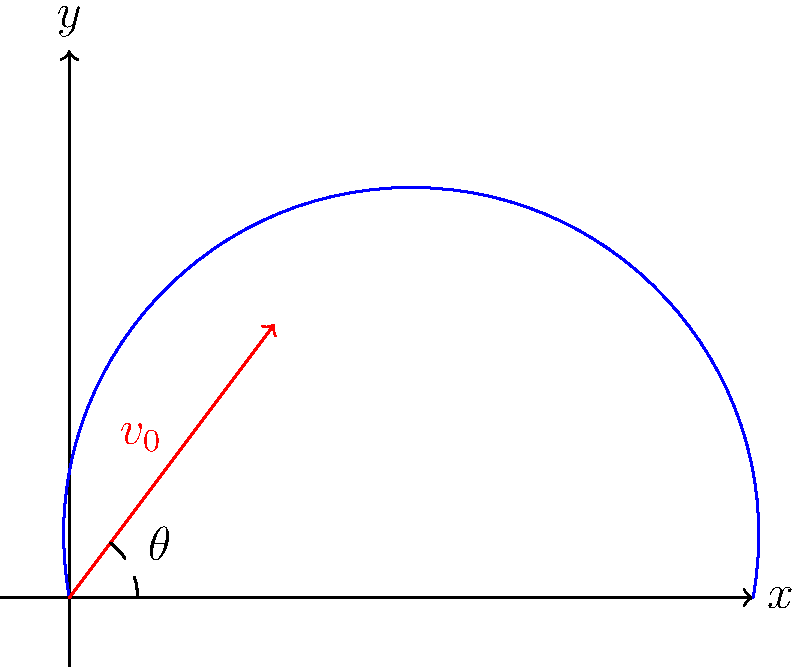As a collector of rare basketball artifacts, you've acquired a vintage mechanical basketball shooter. To maximize its effectiveness, you need to determine the optimal launch angle. Given that the initial velocity ($v_0$) of the ball is 15 m/s and neglecting air resistance, what is the optimal angle ($\theta$) for achieving the maximum range? Express your answer in degrees, rounded to the nearest whole number. To find the optimal angle for maximum range, we can follow these steps:

1) The range (R) of a projectile launched from ground level is given by the equation:

   $$R = \frac{v_0^2 \sin(2\theta)}{g}$$

   where $v_0$ is the initial velocity, $\theta$ is the launch angle, and $g$ is the acceleration due to gravity (9.8 m/s²).

2) To maximize the range, we need to maximize $\sin(2\theta)$. The sine function reaches its maximum value of 1 when its argument is 90°.

3) Therefore, for maximum range:

   $$2\theta = 90°$$

4) Solving for $\theta$:

   $$\theta = 45°$$

5) This result is independent of the initial velocity and the acceleration due to gravity, making it universally applicable for all projectile motions in a uniform gravitational field without air resistance.

6) In the context of basketball, this optimal angle might need slight adjustments due to factors like the height of the shooter and air resistance, but 45° serves as a good theoretical starting point.
Answer: 45° 